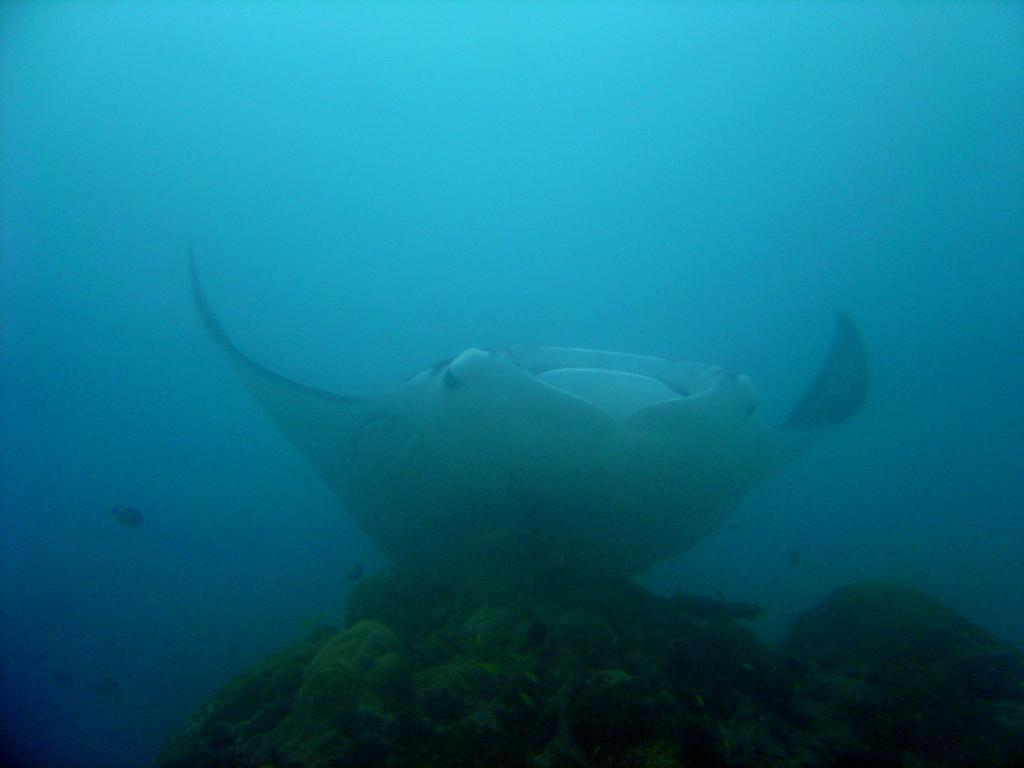Where was the image taken? The image is taken in the sea. What can be seen in the middle of the image? There is a fish in the water in the middle of the image. What is visible at the bottom of the image? There are coral reefs at the bottom of the image. Are there any news articles visible in the image? There are no news articles present in the image, as it is taken underwater in the sea. Can you see any vest-like clothing on the fish in the image? There is no clothing visible on the fish in the image, as it is a natural underwater scene. 